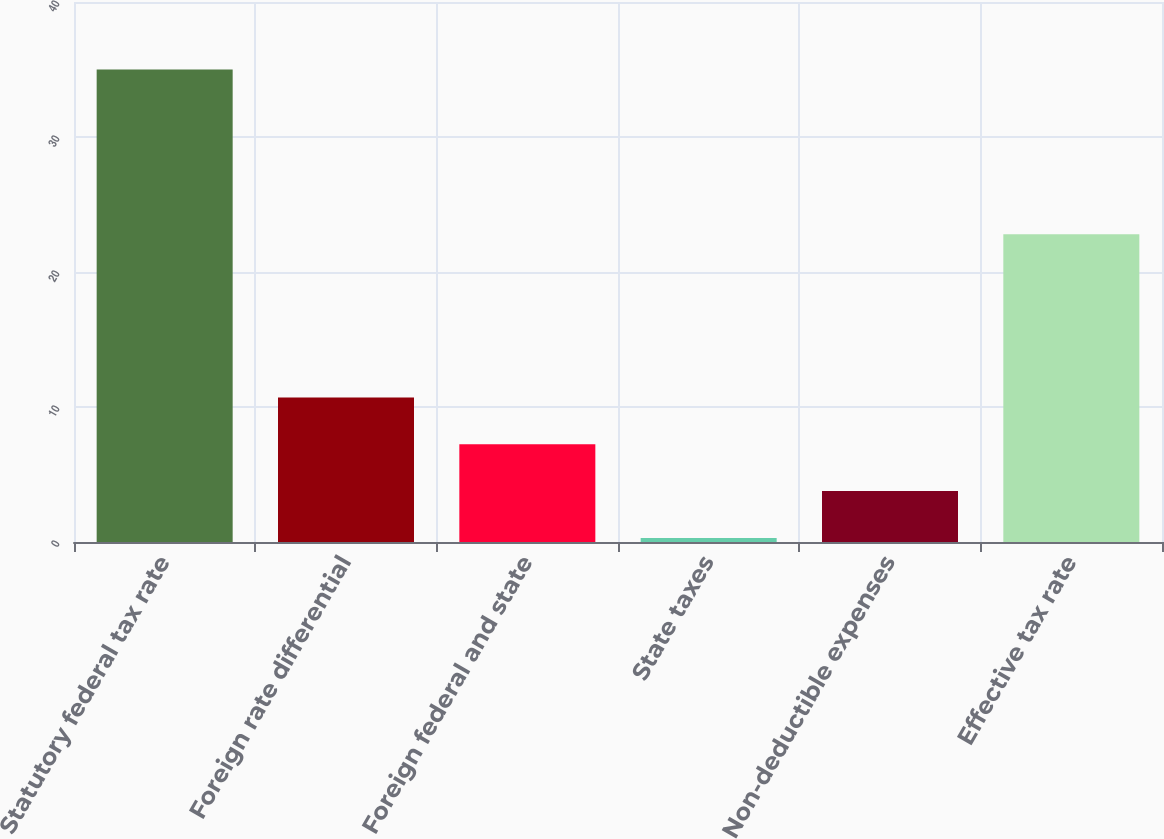Convert chart. <chart><loc_0><loc_0><loc_500><loc_500><bar_chart><fcel>Statutory federal tax rate<fcel>Foreign rate differential<fcel>Foreign federal and state<fcel>State taxes<fcel>Non-deductible expenses<fcel>Effective tax rate<nl><fcel>35<fcel>10.71<fcel>7.24<fcel>0.3<fcel>3.77<fcel>22.8<nl></chart> 